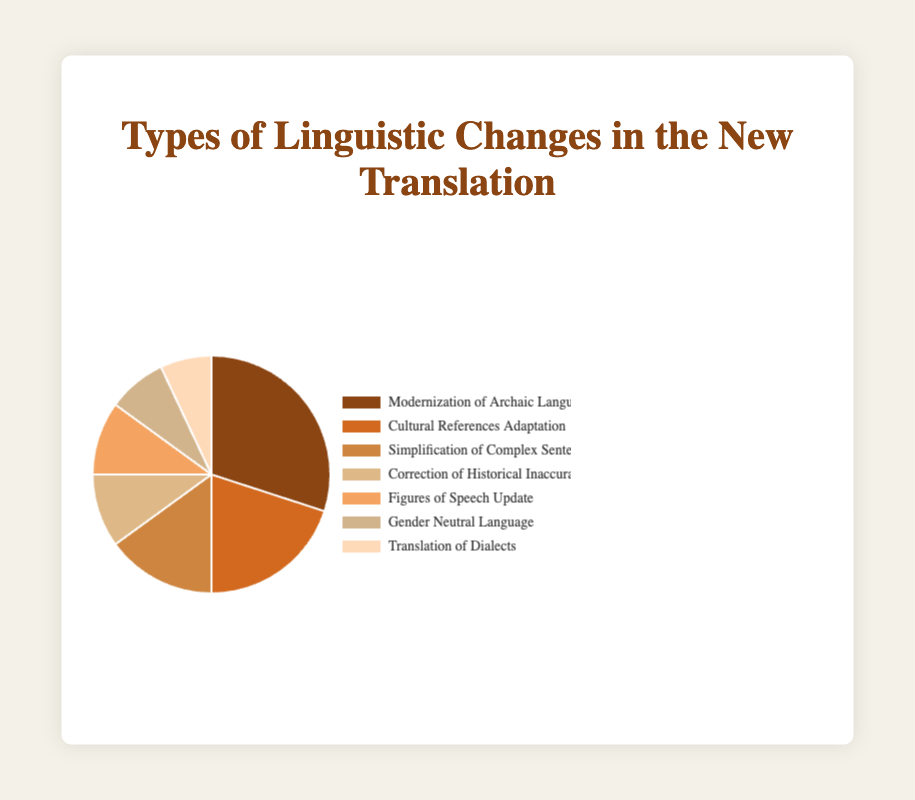Which type of linguistic change has the largest percentage? The type of linguistic change with the largest percentage is the one with the highest value in the pie chart. "Modernization of Archaic Language" has the largest percentage at 30%.
Answer: Modernization of Archaic Language What is the combined percentage of "Modernization of Archaic Language" and "Cultural References Adaptation"? Add the percentage of "Modernization of Archaic Language" (30%) to the percentage of "Cultural References Adaptation" (20%). The combined percentage is 30% + 20% = 50%.
Answer: 50% How many types of linguistic changes have a percentage less than 10%? Count the types with percentages under 10%. "Gender Neutral Language" (8%) and "Translation of Dialects" (7%) are less than 10%. There are 2 types.
Answer: 2 Which linguistic change has a percentage higher than "Figures of Speech Update" but lower than "Simplification of Complex Sentences"? "Figures of Speech Update" has 10%, and "Simplification of Complex Sentences" has 15%. The only type with a percentage in between these two is "Correction of Historical Inaccuracies" at 10%.
Answer: Correction of Historical Inaccuracies What proportion of the total percentage is dedicated to "Gender Neutral Language" and "Translation of Dialects"? Combine the percentages of "Gender Neutral Language" (8%) and "Translation of Dialects" (7%). The total is 8% + 7% = 15%. This is the combined proportion.
Answer: 15% Which type of linguistic change is associated with the lightest color on the chart? Observing the chart, the segment with the lightest color is labeled "Translation of Dialects."
Answer: Translation of Dialects Does "Simplification of Complex Sentences" have a higher percentage than "Correction of Historical Inaccuracies"? Compare the percentages. "Simplification of Complex Sentences" is 15%, and "Correction of Historical Inaccuracies" is 10%. 15% is higher than 10%.
Answer: Yes Is the percentage for "Figures of Speech Update" equal to the percentage for "Correction of Historical Inaccuracies"? Compare the two percentages. Both "Figures of Speech Update" and "Correction of Historical Inaccuracies" have 10%.
Answer: Yes 